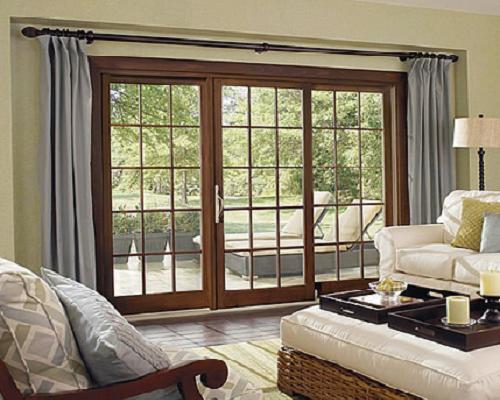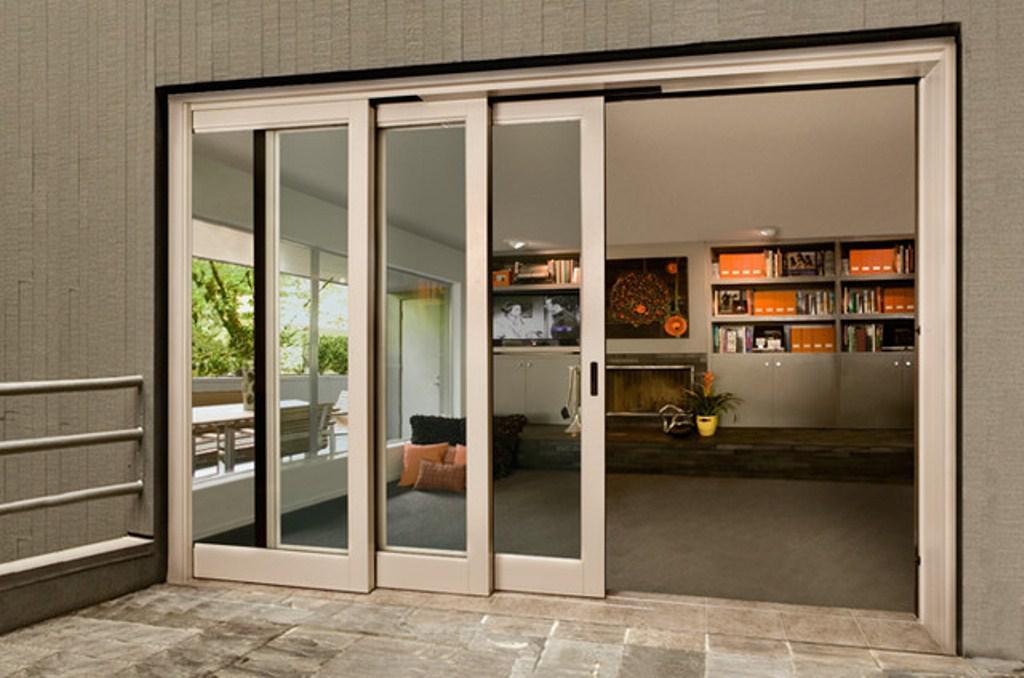The first image is the image on the left, the second image is the image on the right. Examine the images to the left and right. Is the description "The doors in the right image are open." accurate? Answer yes or no. Yes. 